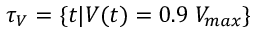<formula> <loc_0><loc_0><loc_500><loc_500>\tau _ { V } = \{ t | V ( t ) = 0 . 9 \, V _ { \max } \}</formula> 